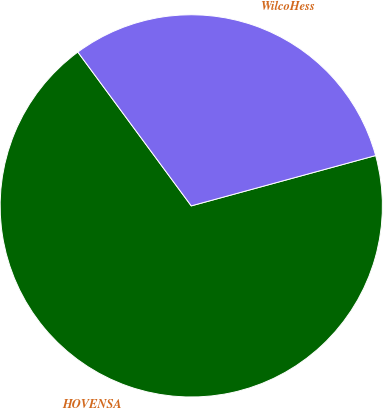Convert chart to OTSL. <chart><loc_0><loc_0><loc_500><loc_500><pie_chart><fcel>HOVENSA<fcel>WilcoHess<nl><fcel>69.13%<fcel>30.87%<nl></chart> 